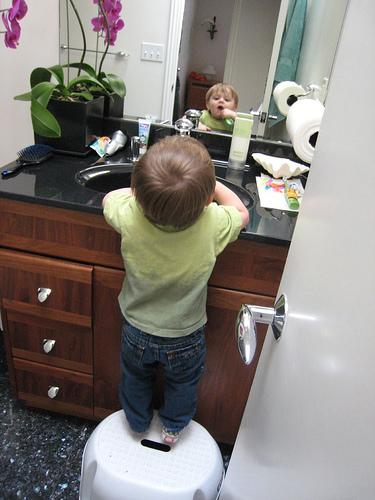Who is the little boy looking at?
Be succinct. Himself. What is the little boy doing?
Short answer required. Brushing teeth. What color is the flower?
Give a very brief answer. Purple. 